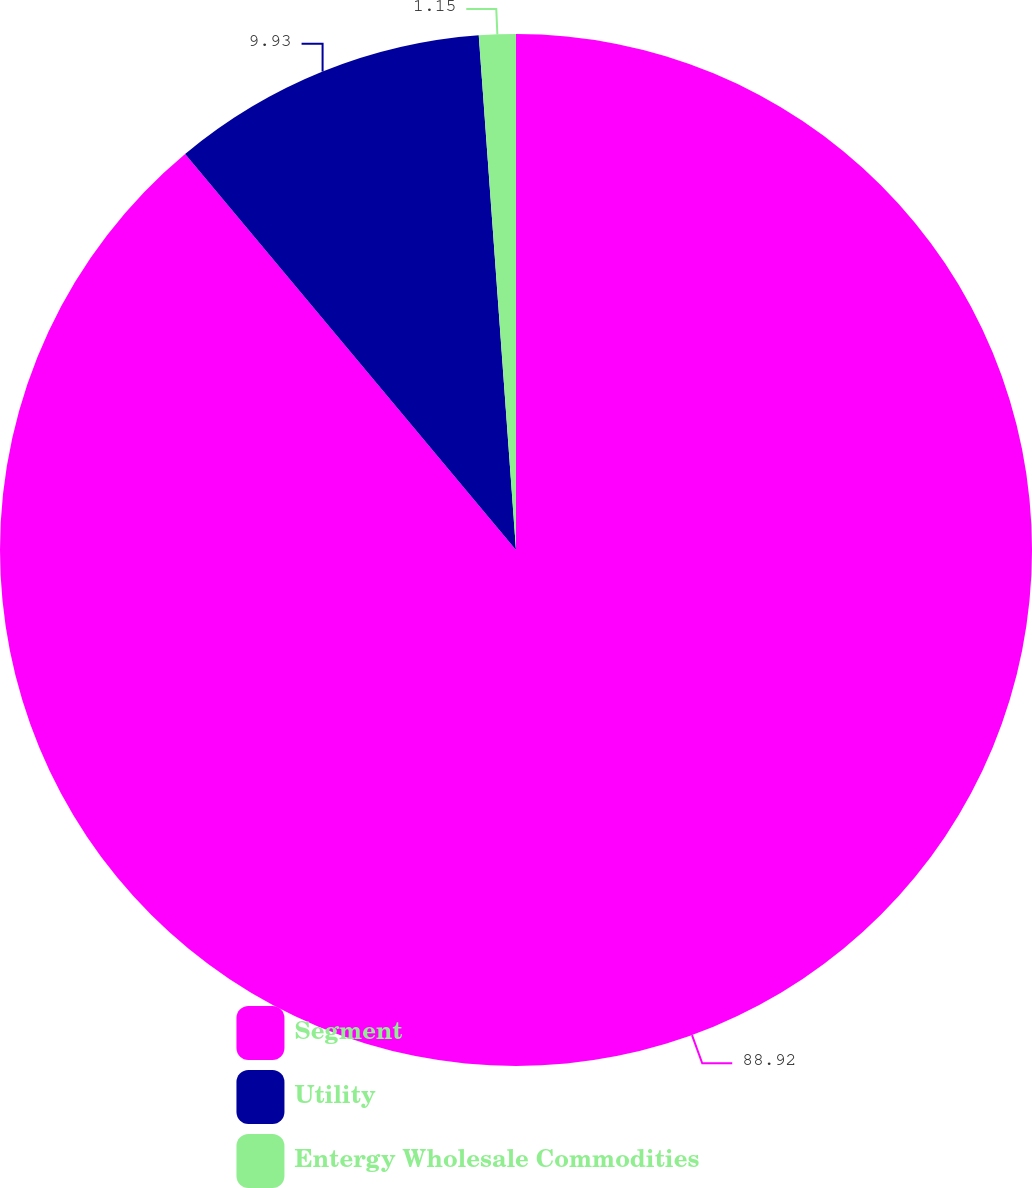Convert chart. <chart><loc_0><loc_0><loc_500><loc_500><pie_chart><fcel>Segment<fcel>Utility<fcel>Entergy Wholesale Commodities<nl><fcel>88.92%<fcel>9.93%<fcel>1.15%<nl></chart> 